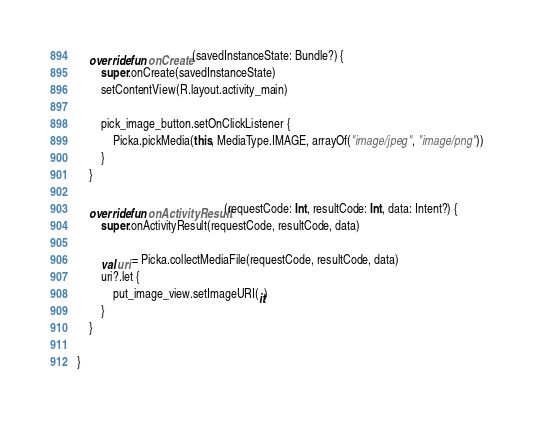<code> <loc_0><loc_0><loc_500><loc_500><_Kotlin_>    override fun onCreate(savedInstanceState: Bundle?) {
        super.onCreate(savedInstanceState)
        setContentView(R.layout.activity_main)

        pick_image_button.setOnClickListener {
            Picka.pickMedia(this, MediaType.IMAGE, arrayOf("image/jpeg", "image/png"))
        }
    }

    override fun onActivityResult(requestCode: Int, resultCode: Int, data: Intent?) {
        super.onActivityResult(requestCode, resultCode, data)

        val uri = Picka.collectMediaFile(requestCode, resultCode, data)
        uri?.let {
            put_image_view.setImageURI(it)
        }
    }

}
</code> 